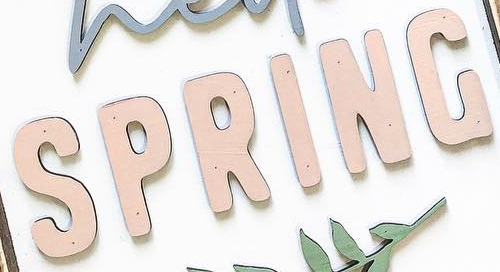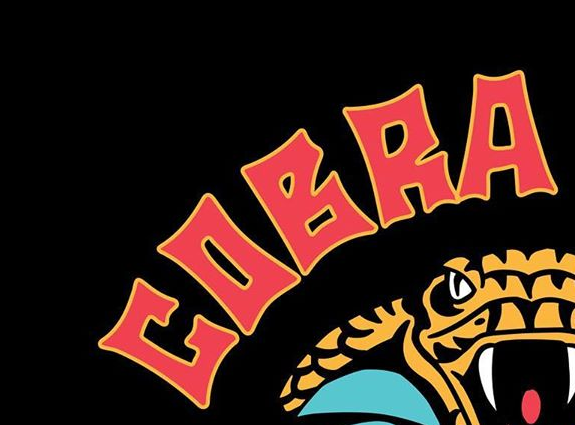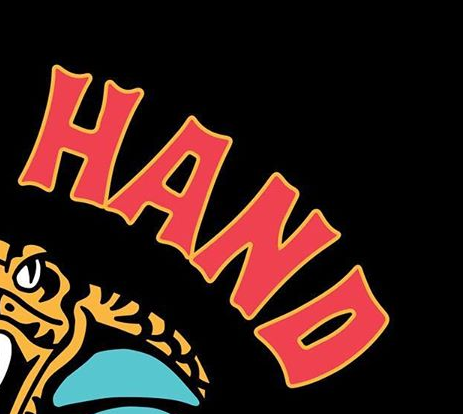What text appears in these images from left to right, separated by a semicolon? SPRING; COBRA; HAND 